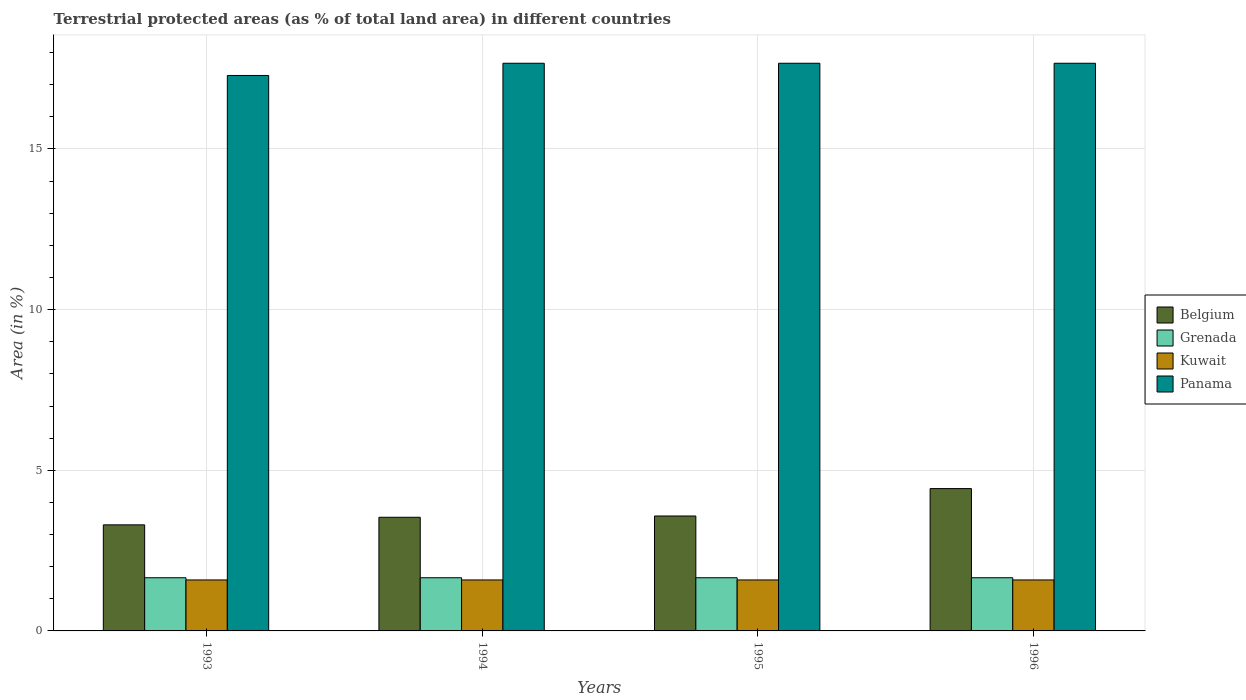How many different coloured bars are there?
Your answer should be compact. 4. Are the number of bars per tick equal to the number of legend labels?
Offer a terse response. Yes. How many bars are there on the 3rd tick from the left?
Offer a terse response. 4. How many bars are there on the 4th tick from the right?
Offer a terse response. 4. What is the label of the 2nd group of bars from the left?
Ensure brevity in your answer.  1994. In how many cases, is the number of bars for a given year not equal to the number of legend labels?
Provide a short and direct response. 0. What is the percentage of terrestrial protected land in Panama in 1994?
Provide a succinct answer. 17.67. Across all years, what is the maximum percentage of terrestrial protected land in Kuwait?
Provide a succinct answer. 1.59. Across all years, what is the minimum percentage of terrestrial protected land in Belgium?
Ensure brevity in your answer.  3.3. In which year was the percentage of terrestrial protected land in Panama minimum?
Offer a very short reply. 1993. What is the total percentage of terrestrial protected land in Panama in the graph?
Your response must be concise. 70.29. What is the difference between the percentage of terrestrial protected land in Belgium in 1994 and that in 1996?
Your response must be concise. -0.89. What is the difference between the percentage of terrestrial protected land in Kuwait in 1996 and the percentage of terrestrial protected land in Belgium in 1994?
Your answer should be compact. -1.95. What is the average percentage of terrestrial protected land in Kuwait per year?
Provide a short and direct response. 1.59. In the year 1995, what is the difference between the percentage of terrestrial protected land in Belgium and percentage of terrestrial protected land in Kuwait?
Your answer should be compact. 1.99. In how many years, is the percentage of terrestrial protected land in Belgium greater than 2 %?
Ensure brevity in your answer.  4. What is the ratio of the percentage of terrestrial protected land in Kuwait in 1993 to that in 1995?
Offer a terse response. 1. Is the difference between the percentage of terrestrial protected land in Belgium in 1993 and 1994 greater than the difference between the percentage of terrestrial protected land in Kuwait in 1993 and 1994?
Give a very brief answer. No. Is the sum of the percentage of terrestrial protected land in Kuwait in 1994 and 1995 greater than the maximum percentage of terrestrial protected land in Belgium across all years?
Provide a succinct answer. No. What does the 4th bar from the left in 1996 represents?
Provide a succinct answer. Panama. What does the 1st bar from the right in 1994 represents?
Ensure brevity in your answer.  Panama. How many bars are there?
Offer a terse response. 16. Are all the bars in the graph horizontal?
Your answer should be compact. No. How many years are there in the graph?
Offer a terse response. 4. Does the graph contain any zero values?
Ensure brevity in your answer.  No. Where does the legend appear in the graph?
Your answer should be very brief. Center right. How are the legend labels stacked?
Provide a succinct answer. Vertical. What is the title of the graph?
Offer a terse response. Terrestrial protected areas (as % of total land area) in different countries. What is the label or title of the X-axis?
Offer a terse response. Years. What is the label or title of the Y-axis?
Provide a short and direct response. Area (in %). What is the Area (in %) of Belgium in 1993?
Make the answer very short. 3.3. What is the Area (in %) in Grenada in 1993?
Keep it short and to the point. 1.66. What is the Area (in %) in Kuwait in 1993?
Your answer should be very brief. 1.59. What is the Area (in %) of Panama in 1993?
Your response must be concise. 17.29. What is the Area (in %) of Belgium in 1994?
Provide a short and direct response. 3.54. What is the Area (in %) in Grenada in 1994?
Make the answer very short. 1.66. What is the Area (in %) of Kuwait in 1994?
Your answer should be compact. 1.59. What is the Area (in %) in Panama in 1994?
Offer a terse response. 17.67. What is the Area (in %) in Belgium in 1995?
Ensure brevity in your answer.  3.58. What is the Area (in %) in Grenada in 1995?
Provide a short and direct response. 1.66. What is the Area (in %) in Kuwait in 1995?
Your response must be concise. 1.59. What is the Area (in %) of Panama in 1995?
Keep it short and to the point. 17.67. What is the Area (in %) in Belgium in 1996?
Make the answer very short. 4.43. What is the Area (in %) of Grenada in 1996?
Keep it short and to the point. 1.66. What is the Area (in %) in Kuwait in 1996?
Your response must be concise. 1.59. What is the Area (in %) of Panama in 1996?
Offer a terse response. 17.67. Across all years, what is the maximum Area (in %) of Belgium?
Make the answer very short. 4.43. Across all years, what is the maximum Area (in %) in Grenada?
Offer a very short reply. 1.66. Across all years, what is the maximum Area (in %) of Kuwait?
Ensure brevity in your answer.  1.59. Across all years, what is the maximum Area (in %) of Panama?
Offer a terse response. 17.67. Across all years, what is the minimum Area (in %) of Belgium?
Give a very brief answer. 3.3. Across all years, what is the minimum Area (in %) in Grenada?
Ensure brevity in your answer.  1.66. Across all years, what is the minimum Area (in %) of Kuwait?
Your answer should be compact. 1.59. Across all years, what is the minimum Area (in %) of Panama?
Your answer should be very brief. 17.29. What is the total Area (in %) in Belgium in the graph?
Make the answer very short. 14.85. What is the total Area (in %) in Grenada in the graph?
Give a very brief answer. 6.62. What is the total Area (in %) of Kuwait in the graph?
Give a very brief answer. 6.35. What is the total Area (in %) of Panama in the graph?
Provide a short and direct response. 70.29. What is the difference between the Area (in %) in Belgium in 1993 and that in 1994?
Offer a very short reply. -0.24. What is the difference between the Area (in %) in Grenada in 1993 and that in 1994?
Your answer should be compact. 0. What is the difference between the Area (in %) of Kuwait in 1993 and that in 1994?
Offer a very short reply. 0. What is the difference between the Area (in %) in Panama in 1993 and that in 1994?
Give a very brief answer. -0.38. What is the difference between the Area (in %) of Belgium in 1993 and that in 1995?
Provide a succinct answer. -0.28. What is the difference between the Area (in %) in Grenada in 1993 and that in 1995?
Make the answer very short. 0. What is the difference between the Area (in %) of Panama in 1993 and that in 1995?
Your answer should be compact. -0.38. What is the difference between the Area (in %) of Belgium in 1993 and that in 1996?
Your answer should be very brief. -1.13. What is the difference between the Area (in %) of Grenada in 1993 and that in 1996?
Give a very brief answer. 0. What is the difference between the Area (in %) of Panama in 1993 and that in 1996?
Make the answer very short. -0.38. What is the difference between the Area (in %) of Belgium in 1994 and that in 1995?
Your response must be concise. -0.04. What is the difference between the Area (in %) of Kuwait in 1994 and that in 1995?
Ensure brevity in your answer.  0. What is the difference between the Area (in %) in Panama in 1994 and that in 1995?
Make the answer very short. 0. What is the difference between the Area (in %) of Belgium in 1994 and that in 1996?
Provide a short and direct response. -0.89. What is the difference between the Area (in %) of Grenada in 1994 and that in 1996?
Ensure brevity in your answer.  0. What is the difference between the Area (in %) in Panama in 1994 and that in 1996?
Your response must be concise. 0. What is the difference between the Area (in %) of Belgium in 1995 and that in 1996?
Keep it short and to the point. -0.85. What is the difference between the Area (in %) in Grenada in 1995 and that in 1996?
Give a very brief answer. 0. What is the difference between the Area (in %) of Belgium in 1993 and the Area (in %) of Grenada in 1994?
Ensure brevity in your answer.  1.65. What is the difference between the Area (in %) of Belgium in 1993 and the Area (in %) of Kuwait in 1994?
Your response must be concise. 1.71. What is the difference between the Area (in %) in Belgium in 1993 and the Area (in %) in Panama in 1994?
Your answer should be compact. -14.37. What is the difference between the Area (in %) in Grenada in 1993 and the Area (in %) in Kuwait in 1994?
Provide a short and direct response. 0.07. What is the difference between the Area (in %) in Grenada in 1993 and the Area (in %) in Panama in 1994?
Your answer should be compact. -16.01. What is the difference between the Area (in %) of Kuwait in 1993 and the Area (in %) of Panama in 1994?
Your answer should be compact. -16.08. What is the difference between the Area (in %) of Belgium in 1993 and the Area (in %) of Grenada in 1995?
Offer a terse response. 1.65. What is the difference between the Area (in %) of Belgium in 1993 and the Area (in %) of Kuwait in 1995?
Your answer should be very brief. 1.71. What is the difference between the Area (in %) of Belgium in 1993 and the Area (in %) of Panama in 1995?
Offer a very short reply. -14.37. What is the difference between the Area (in %) in Grenada in 1993 and the Area (in %) in Kuwait in 1995?
Your answer should be compact. 0.07. What is the difference between the Area (in %) of Grenada in 1993 and the Area (in %) of Panama in 1995?
Your answer should be compact. -16.01. What is the difference between the Area (in %) in Kuwait in 1993 and the Area (in %) in Panama in 1995?
Give a very brief answer. -16.08. What is the difference between the Area (in %) of Belgium in 1993 and the Area (in %) of Grenada in 1996?
Provide a short and direct response. 1.65. What is the difference between the Area (in %) in Belgium in 1993 and the Area (in %) in Kuwait in 1996?
Give a very brief answer. 1.71. What is the difference between the Area (in %) of Belgium in 1993 and the Area (in %) of Panama in 1996?
Your response must be concise. -14.37. What is the difference between the Area (in %) of Grenada in 1993 and the Area (in %) of Kuwait in 1996?
Your response must be concise. 0.07. What is the difference between the Area (in %) in Grenada in 1993 and the Area (in %) in Panama in 1996?
Your answer should be very brief. -16.01. What is the difference between the Area (in %) of Kuwait in 1993 and the Area (in %) of Panama in 1996?
Provide a succinct answer. -16.08. What is the difference between the Area (in %) of Belgium in 1994 and the Area (in %) of Grenada in 1995?
Give a very brief answer. 1.88. What is the difference between the Area (in %) of Belgium in 1994 and the Area (in %) of Kuwait in 1995?
Offer a very short reply. 1.95. What is the difference between the Area (in %) in Belgium in 1994 and the Area (in %) in Panama in 1995?
Ensure brevity in your answer.  -14.13. What is the difference between the Area (in %) of Grenada in 1994 and the Area (in %) of Kuwait in 1995?
Provide a succinct answer. 0.07. What is the difference between the Area (in %) in Grenada in 1994 and the Area (in %) in Panama in 1995?
Offer a terse response. -16.01. What is the difference between the Area (in %) in Kuwait in 1994 and the Area (in %) in Panama in 1995?
Provide a short and direct response. -16.08. What is the difference between the Area (in %) of Belgium in 1994 and the Area (in %) of Grenada in 1996?
Your answer should be compact. 1.88. What is the difference between the Area (in %) of Belgium in 1994 and the Area (in %) of Kuwait in 1996?
Your answer should be very brief. 1.95. What is the difference between the Area (in %) in Belgium in 1994 and the Area (in %) in Panama in 1996?
Offer a terse response. -14.13. What is the difference between the Area (in %) of Grenada in 1994 and the Area (in %) of Kuwait in 1996?
Give a very brief answer. 0.07. What is the difference between the Area (in %) of Grenada in 1994 and the Area (in %) of Panama in 1996?
Give a very brief answer. -16.01. What is the difference between the Area (in %) in Kuwait in 1994 and the Area (in %) in Panama in 1996?
Your answer should be very brief. -16.08. What is the difference between the Area (in %) of Belgium in 1995 and the Area (in %) of Grenada in 1996?
Provide a succinct answer. 1.92. What is the difference between the Area (in %) in Belgium in 1995 and the Area (in %) in Kuwait in 1996?
Make the answer very short. 1.99. What is the difference between the Area (in %) in Belgium in 1995 and the Area (in %) in Panama in 1996?
Offer a very short reply. -14.09. What is the difference between the Area (in %) in Grenada in 1995 and the Area (in %) in Kuwait in 1996?
Ensure brevity in your answer.  0.07. What is the difference between the Area (in %) of Grenada in 1995 and the Area (in %) of Panama in 1996?
Offer a very short reply. -16.01. What is the difference between the Area (in %) of Kuwait in 1995 and the Area (in %) of Panama in 1996?
Provide a succinct answer. -16.08. What is the average Area (in %) in Belgium per year?
Ensure brevity in your answer.  3.71. What is the average Area (in %) in Grenada per year?
Offer a very short reply. 1.66. What is the average Area (in %) in Kuwait per year?
Give a very brief answer. 1.59. What is the average Area (in %) in Panama per year?
Keep it short and to the point. 17.57. In the year 1993, what is the difference between the Area (in %) in Belgium and Area (in %) in Grenada?
Ensure brevity in your answer.  1.65. In the year 1993, what is the difference between the Area (in %) in Belgium and Area (in %) in Kuwait?
Ensure brevity in your answer.  1.71. In the year 1993, what is the difference between the Area (in %) in Belgium and Area (in %) in Panama?
Provide a succinct answer. -13.99. In the year 1993, what is the difference between the Area (in %) in Grenada and Area (in %) in Kuwait?
Provide a short and direct response. 0.07. In the year 1993, what is the difference between the Area (in %) of Grenada and Area (in %) of Panama?
Ensure brevity in your answer.  -15.63. In the year 1993, what is the difference between the Area (in %) of Kuwait and Area (in %) of Panama?
Provide a succinct answer. -15.7. In the year 1994, what is the difference between the Area (in %) in Belgium and Area (in %) in Grenada?
Make the answer very short. 1.88. In the year 1994, what is the difference between the Area (in %) of Belgium and Area (in %) of Kuwait?
Offer a terse response. 1.95. In the year 1994, what is the difference between the Area (in %) of Belgium and Area (in %) of Panama?
Provide a succinct answer. -14.13. In the year 1994, what is the difference between the Area (in %) of Grenada and Area (in %) of Kuwait?
Give a very brief answer. 0.07. In the year 1994, what is the difference between the Area (in %) of Grenada and Area (in %) of Panama?
Offer a very short reply. -16.01. In the year 1994, what is the difference between the Area (in %) in Kuwait and Area (in %) in Panama?
Keep it short and to the point. -16.08. In the year 1995, what is the difference between the Area (in %) of Belgium and Area (in %) of Grenada?
Ensure brevity in your answer.  1.92. In the year 1995, what is the difference between the Area (in %) in Belgium and Area (in %) in Kuwait?
Offer a terse response. 1.99. In the year 1995, what is the difference between the Area (in %) in Belgium and Area (in %) in Panama?
Give a very brief answer. -14.09. In the year 1995, what is the difference between the Area (in %) of Grenada and Area (in %) of Kuwait?
Offer a very short reply. 0.07. In the year 1995, what is the difference between the Area (in %) in Grenada and Area (in %) in Panama?
Give a very brief answer. -16.01. In the year 1995, what is the difference between the Area (in %) in Kuwait and Area (in %) in Panama?
Keep it short and to the point. -16.08. In the year 1996, what is the difference between the Area (in %) of Belgium and Area (in %) of Grenada?
Provide a succinct answer. 2.77. In the year 1996, what is the difference between the Area (in %) of Belgium and Area (in %) of Kuwait?
Provide a short and direct response. 2.84. In the year 1996, what is the difference between the Area (in %) in Belgium and Area (in %) in Panama?
Your answer should be compact. -13.24. In the year 1996, what is the difference between the Area (in %) in Grenada and Area (in %) in Kuwait?
Your response must be concise. 0.07. In the year 1996, what is the difference between the Area (in %) of Grenada and Area (in %) of Panama?
Provide a short and direct response. -16.01. In the year 1996, what is the difference between the Area (in %) of Kuwait and Area (in %) of Panama?
Your answer should be compact. -16.08. What is the ratio of the Area (in %) in Belgium in 1993 to that in 1994?
Make the answer very short. 0.93. What is the ratio of the Area (in %) of Panama in 1993 to that in 1994?
Make the answer very short. 0.98. What is the ratio of the Area (in %) of Belgium in 1993 to that in 1995?
Keep it short and to the point. 0.92. What is the ratio of the Area (in %) of Kuwait in 1993 to that in 1995?
Make the answer very short. 1. What is the ratio of the Area (in %) of Panama in 1993 to that in 1995?
Keep it short and to the point. 0.98. What is the ratio of the Area (in %) in Belgium in 1993 to that in 1996?
Ensure brevity in your answer.  0.75. What is the ratio of the Area (in %) in Grenada in 1993 to that in 1996?
Ensure brevity in your answer.  1. What is the ratio of the Area (in %) in Panama in 1993 to that in 1996?
Offer a terse response. 0.98. What is the ratio of the Area (in %) in Kuwait in 1994 to that in 1995?
Make the answer very short. 1. What is the ratio of the Area (in %) of Panama in 1994 to that in 1995?
Make the answer very short. 1. What is the ratio of the Area (in %) in Belgium in 1994 to that in 1996?
Offer a very short reply. 0.8. What is the ratio of the Area (in %) in Grenada in 1994 to that in 1996?
Offer a terse response. 1. What is the ratio of the Area (in %) of Panama in 1994 to that in 1996?
Provide a succinct answer. 1. What is the ratio of the Area (in %) of Belgium in 1995 to that in 1996?
Provide a short and direct response. 0.81. What is the difference between the highest and the second highest Area (in %) of Belgium?
Offer a very short reply. 0.85. What is the difference between the highest and the second highest Area (in %) in Kuwait?
Offer a terse response. 0. What is the difference between the highest and the second highest Area (in %) of Panama?
Your answer should be very brief. 0. What is the difference between the highest and the lowest Area (in %) of Belgium?
Offer a terse response. 1.13. What is the difference between the highest and the lowest Area (in %) of Grenada?
Make the answer very short. 0. What is the difference between the highest and the lowest Area (in %) in Kuwait?
Offer a very short reply. 0. What is the difference between the highest and the lowest Area (in %) in Panama?
Make the answer very short. 0.38. 